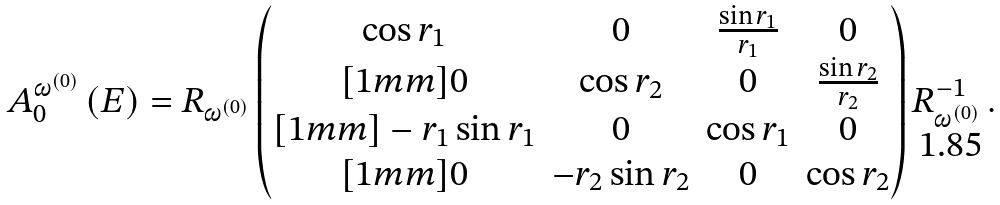Convert formula to latex. <formula><loc_0><loc_0><loc_500><loc_500>A _ { 0 } ^ { \omega ^ { ( 0 ) } } \, ( E ) = R _ { \omega ^ { ( 0 ) } } \begin{pmatrix} \cos r _ { 1 } & 0 & \frac { \sin r _ { 1 } } { r _ { 1 } } & 0 \\ [ 1 m m ] 0 & \cos r _ { 2 } & 0 & \frac { \sin r _ { 2 } } { r _ { 2 } } \\ [ 1 m m ] - r _ { 1 } \sin r _ { 1 } & 0 & \cos r _ { 1 } & 0 \\ [ 1 m m ] 0 & - r _ { 2 } \sin r _ { 2 } & 0 & \cos r _ { 2 } \end{pmatrix} R _ { \omega ^ { ( 0 ) } } ^ { - 1 } \, .</formula> 